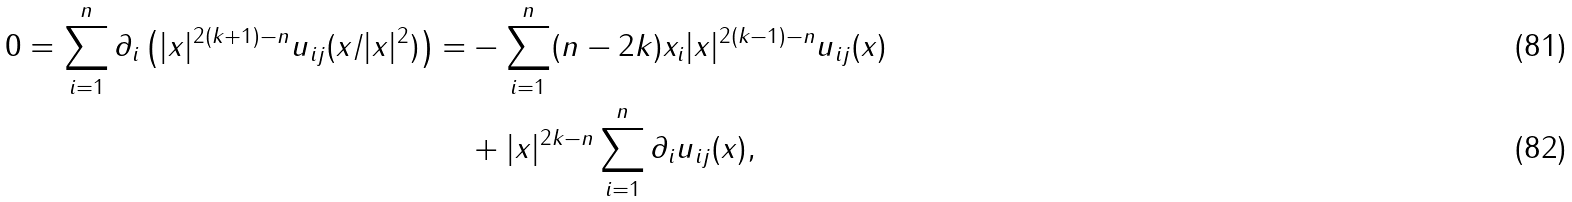Convert formula to latex. <formula><loc_0><loc_0><loc_500><loc_500>0 = \sum _ { i = 1 } ^ { n } \partial _ { i } \left ( | x | ^ { 2 ( k + 1 ) - n } u _ { i j } ( x \slash | x | ^ { 2 } ) \right ) = & - \sum _ { i = 1 } ^ { n } ( n - 2 k ) x _ { i } | x | ^ { 2 ( k - 1 ) - n } u _ { i j } ( x ) \\ & + | x | ^ { 2 k - n } \sum _ { i = 1 } ^ { n } \partial _ { i } u _ { i j } ( x ) ,</formula> 